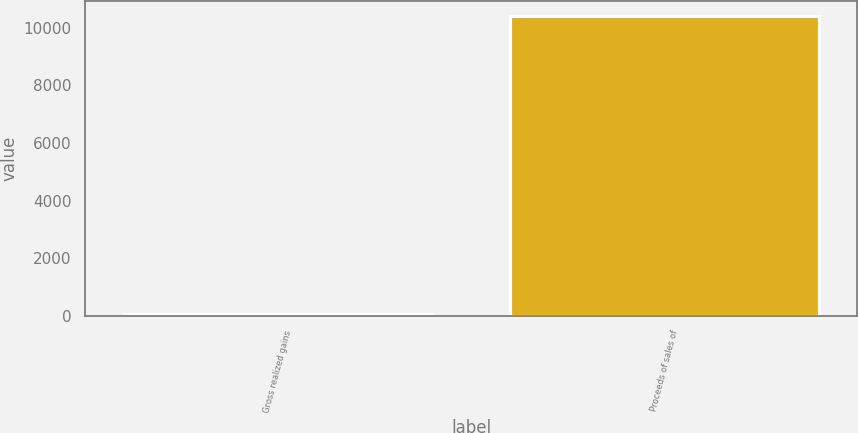Convert chart to OTSL. <chart><loc_0><loc_0><loc_500><loc_500><bar_chart><fcel>Gross realized gains<fcel>Proceeds of sales of<nl><fcel>88<fcel>10398<nl></chart> 